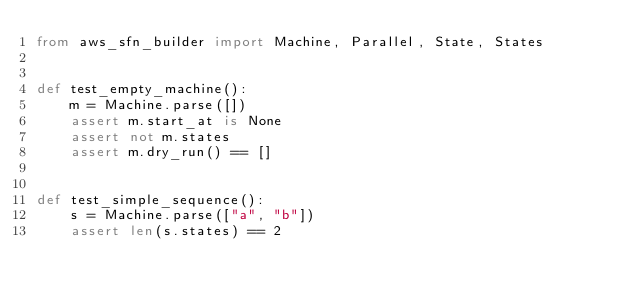<code> <loc_0><loc_0><loc_500><loc_500><_Python_>from aws_sfn_builder import Machine, Parallel, State, States


def test_empty_machine():
    m = Machine.parse([])
    assert m.start_at is None
    assert not m.states
    assert m.dry_run() == []


def test_simple_sequence():
    s = Machine.parse(["a", "b"])
    assert len(s.states) == 2</code> 